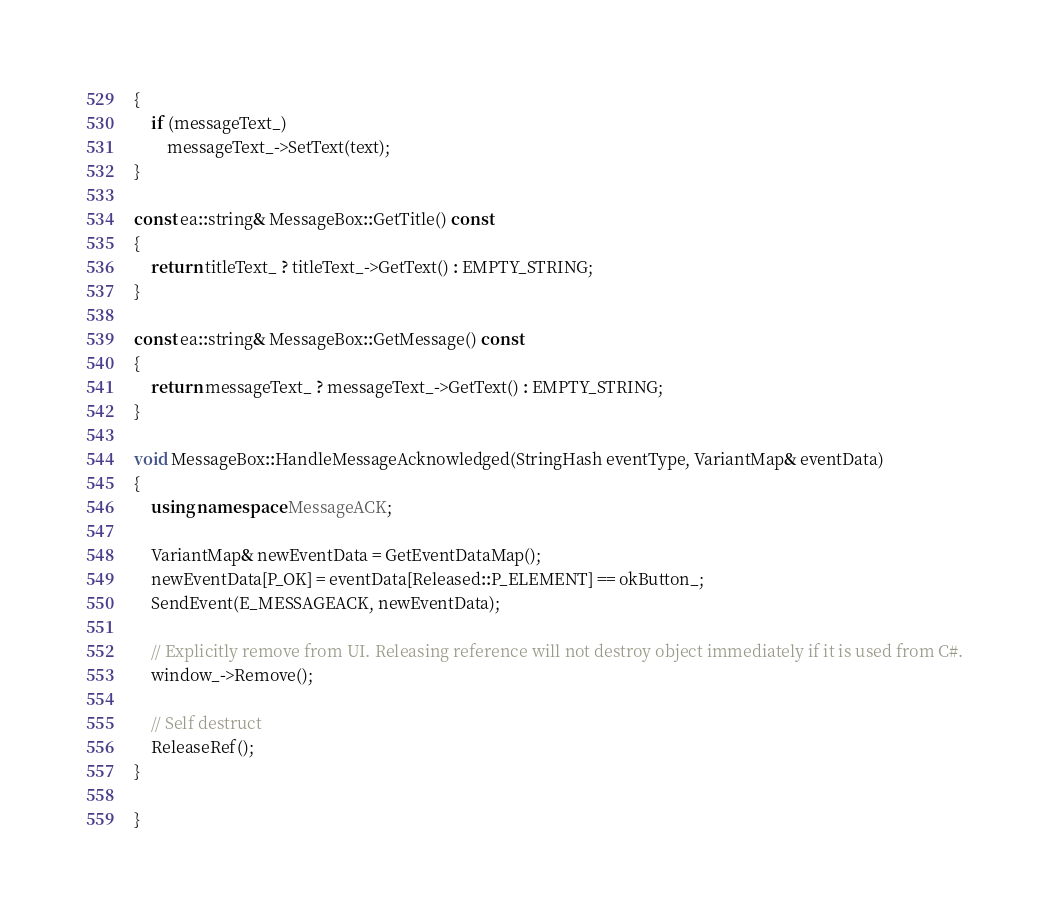Convert code to text. <code><loc_0><loc_0><loc_500><loc_500><_C++_>{
    if (messageText_)
        messageText_->SetText(text);
}

const ea::string& MessageBox::GetTitle() const
{
    return titleText_ ? titleText_->GetText() : EMPTY_STRING;
}

const ea::string& MessageBox::GetMessage() const
{
    return messageText_ ? messageText_->GetText() : EMPTY_STRING;
}

void MessageBox::HandleMessageAcknowledged(StringHash eventType, VariantMap& eventData)
{
    using namespace MessageACK;

    VariantMap& newEventData = GetEventDataMap();
    newEventData[P_OK] = eventData[Released::P_ELEMENT] == okButton_;
    SendEvent(E_MESSAGEACK, newEventData);

    // Explicitly remove from UI. Releasing reference will not destroy object immediately if it is used from C#.
    window_->Remove();

    // Self destruct
    ReleaseRef();
}

}
</code> 